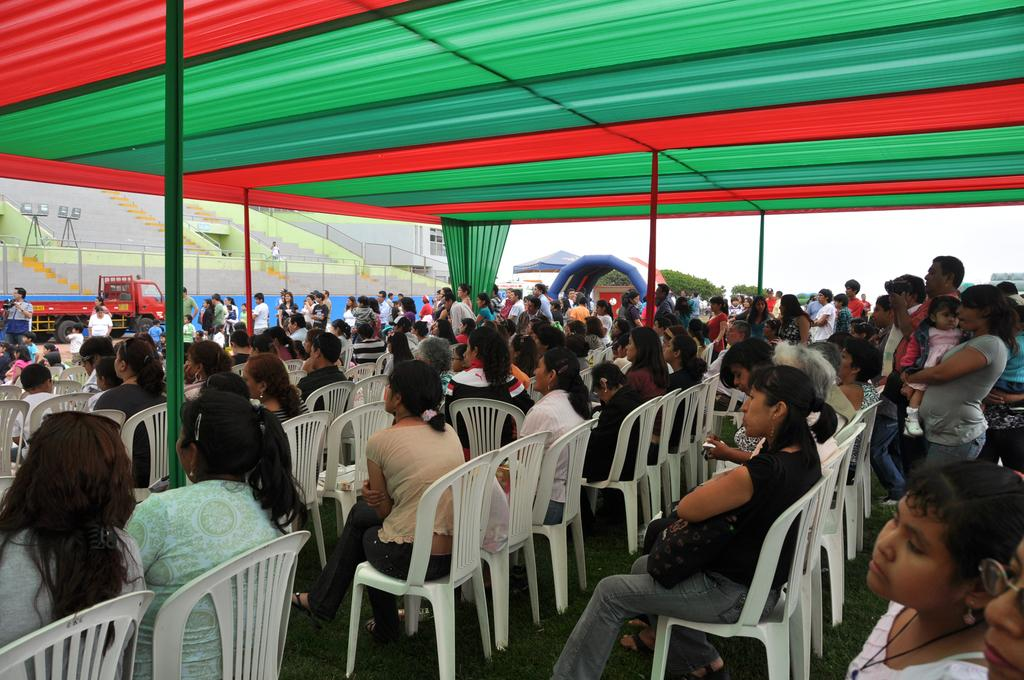How many people are in the image? There are multiple people in the image. What are most of the people doing in the image? Most of the people are sitting on chairs. Are there any people standing in the image? Yes, some people are standing. What else can be seen in the image besides people? There is a vehicle visible in the image. What type of skirt is the train wearing in the image? There is no train present in the image, and therefore no skirt to be worn. 